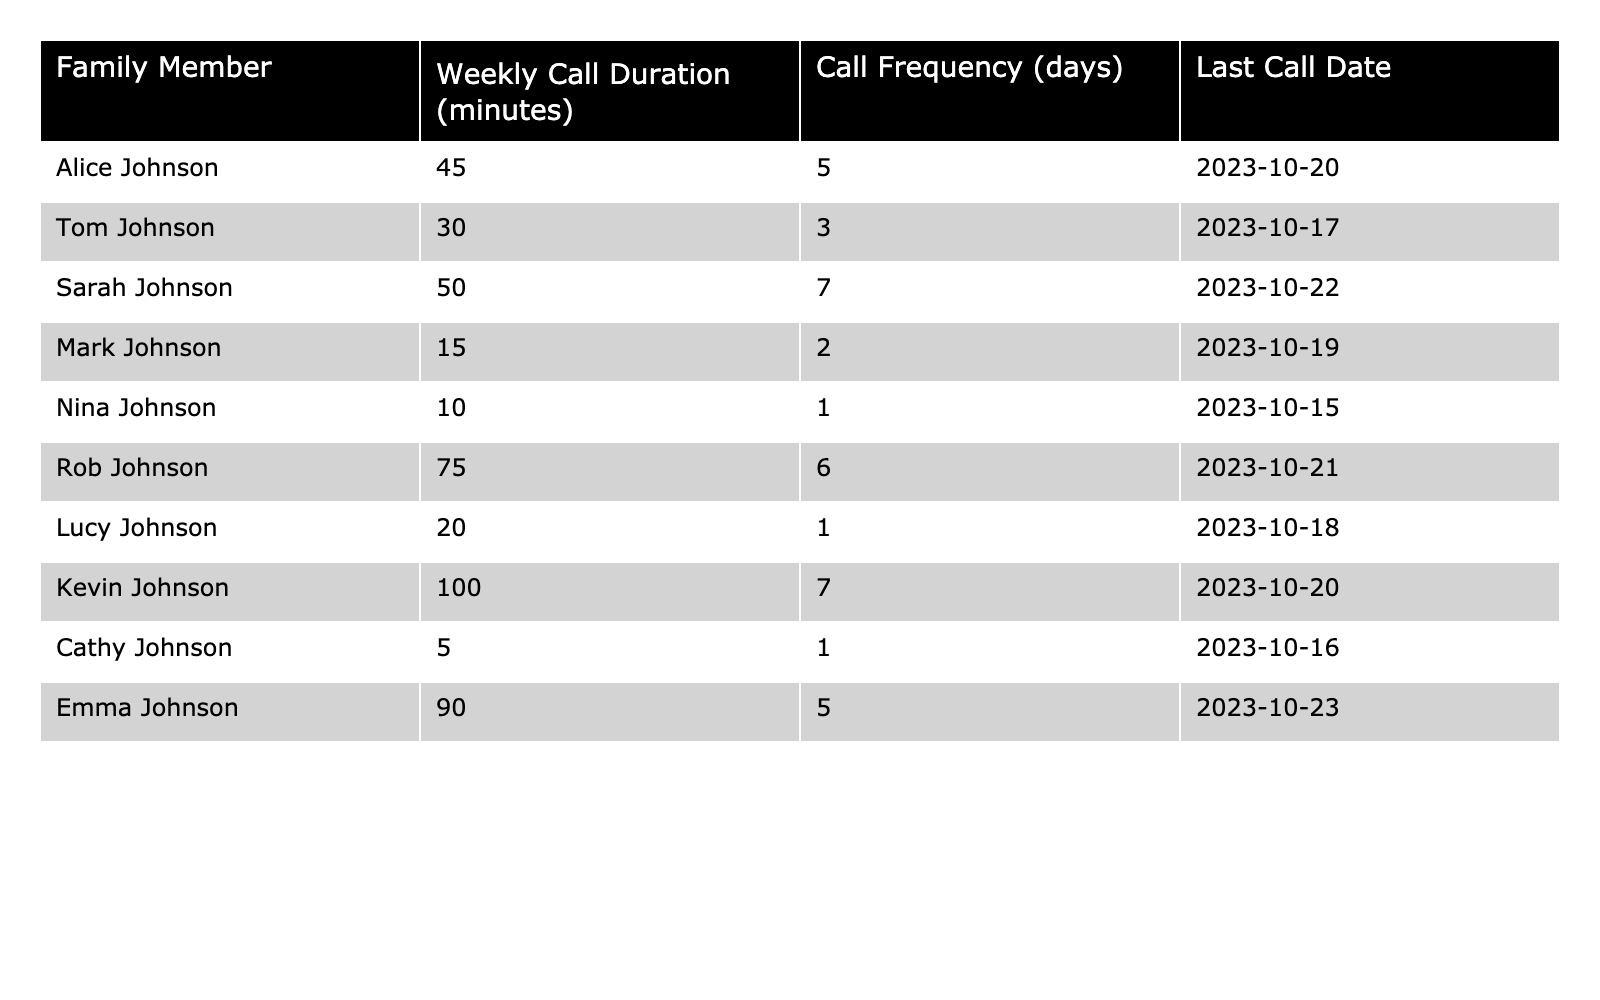What is the total weekly call duration for Tom Johnson? Tom Johnson's weekly call duration is listed as 30 minutes in the table, which is a specific value.
Answer: 30 minutes Who has the highest weekly call duration? By examining the call durations in the table, Kevin Johnson has the highest value at 100 minutes.
Answer: Kevin Johnson Is Sarah Johnson the only family member who calls every day? Checking the table, Sarah Johnson has a call frequency of 7 days, while no one else matches this frequency, confirming she is unique in this regard.
Answer: Yes What is the average weekly call duration of all family members? To calculate the average, first sum all the durations: (45 + 30 + 50 + 15 + 10 + 75 + 20 + 100 + 5 + 90) = 400 minutes. There are 10 family members, so the average is 400/10 = 40 minutes.
Answer: 40 minutes How many family members had a call duration less than 20 minutes? The table shows two family members with durations under 20 minutes: Mark Johnson at 15 minutes and Nina Johnson at 10 minutes. Therefore, there are 2 members.
Answer: 2 What is the difference between the longest and shortest call durations? The longest call duration is 100 minutes (Kevin Johnson) and the shortest is 5 minutes (Cathy Johnson). The difference is 100 - 5 = 95 minutes.
Answer: 95 minutes Which family member had their last call on October 18, 2023? In the last call date column, Lucy Johnson is listed with the date October 18, 2023, indicating she had a call on that date.
Answer: Lucy Johnson If we combine the weekly call durations of Alice and Emma, what do we get? Adding the weekly durations, Alice has 45 minutes and Emma has 90 minutes, giving us 45 + 90 = 135 minutes in total.
Answer: 135 minutes Is it true that Rob Johnson calls more frequently than he has call duration? Rob has a call duration of 75 minutes and a frequency of 6 days. Since his call duration does not exceed 6 days overall, the statement is indeed true.
Answer: Yes Which family member has a call frequency of 1 day and what is their call duration? The table indicates that both Nina Johnson and Cathy Johnson have a call frequency of 1 day, with durations of 10 minutes and 5 minutes respectively.
Answer: Nina Johnson - 10 minutes, Cathy Johnson - 5 minutes 